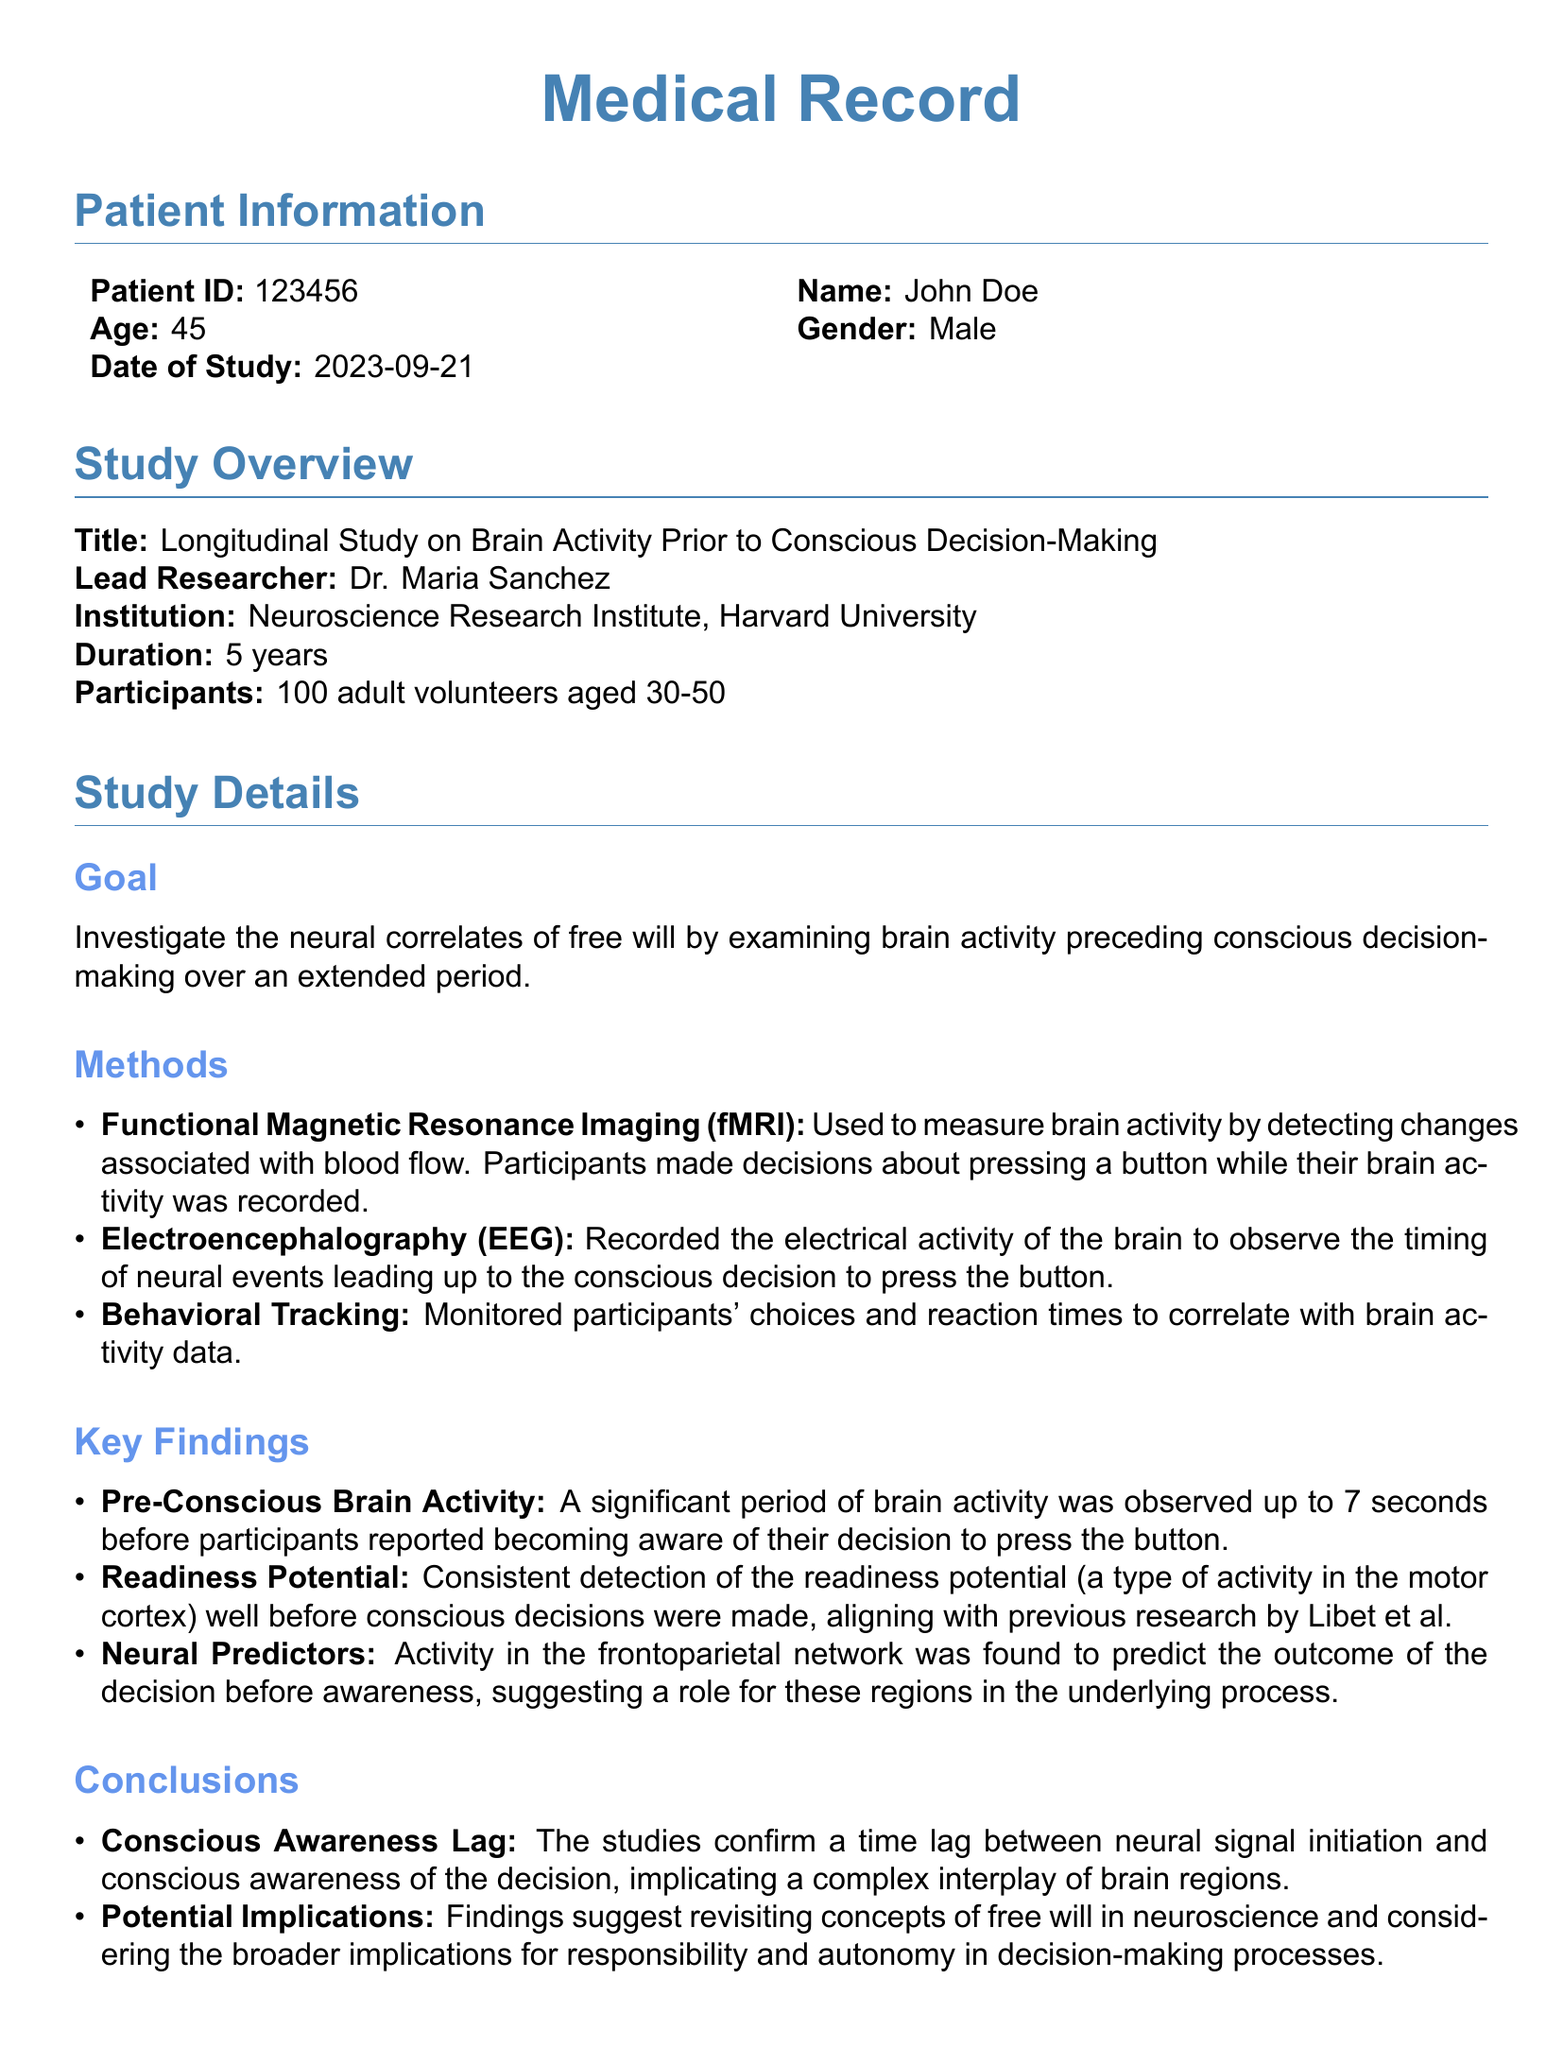What is the patient ID? The patient ID can be found in the Patient Information section of the document.
Answer: 123456 Who is the lead researcher of the study? The lead researcher is mentioned in the Study Overview section.
Answer: Dr. Maria Sanchez What type of brain imaging was used in the study? The methods section specifies the techniques employed in the study.
Answer: Functional Magnetic Resonance Imaging (fMRI) How long is the duration of the study? This information is provided in the Study Overview section of the document.
Answer: 5 years What significant duration of brain activity was observed before conscious awareness? This detail is mentioned in the Key Findings section, which describes crucial results of the study.
Answer: 7 seconds What neural network was found to predict decision outcomes? The Key Findings section highlights this specific brain network's role.
Answer: frontoparietal network What historical research aligns with the findings of readiness potential? This information is referenced in the Key Findings section regarding established literature.
Answer: Libet et al What major implication do the study findings suggest? The Conclusions section summarizes a significant implication of the study findings regarding decision-making.
Answer: revisiting concepts of free will in neuroscience What future research area involves machine learning integration? Future Research mentions potential research directions including technology applications.
Answer: Artificial Intelligence Integration 